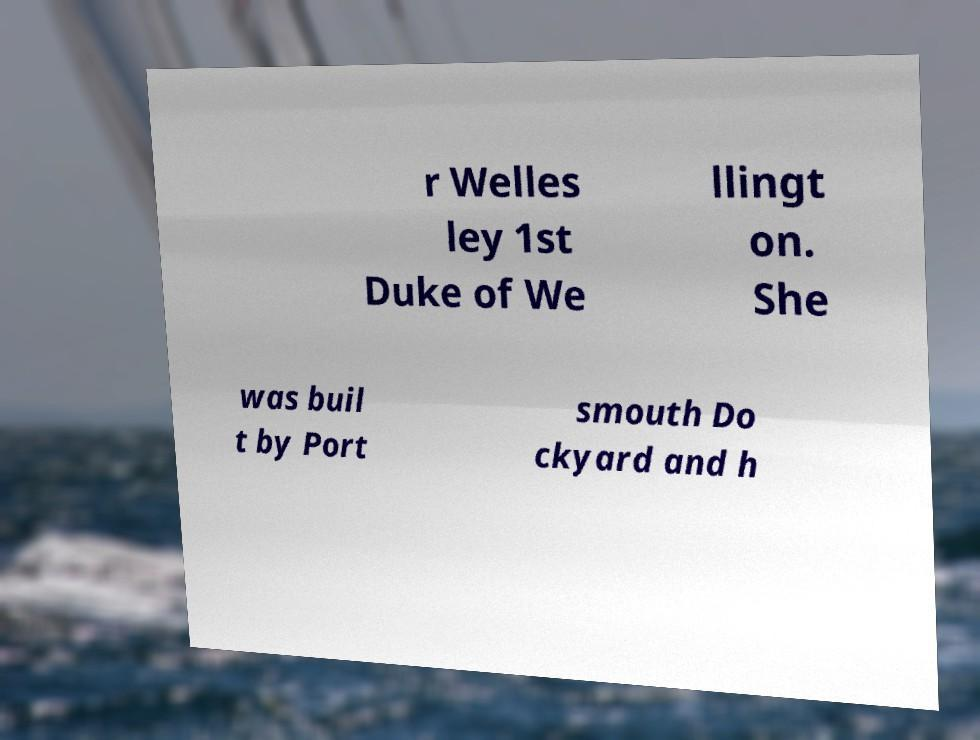Can you accurately transcribe the text from the provided image for me? r Welles ley 1st Duke of We llingt on. She was buil t by Port smouth Do ckyard and h 